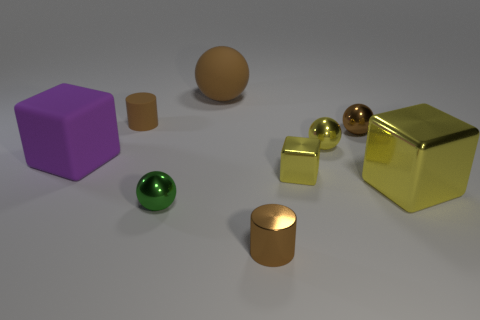Are there more brown matte balls than blue shiny balls?
Provide a succinct answer. Yes. Do the large yellow metallic object and the big brown matte object have the same shape?
Keep it short and to the point. No. There is a small cylinder that is in front of the big cube that is left of the tiny brown shiny ball; what is it made of?
Your answer should be compact. Metal. There is a tiny sphere that is the same color as the big rubber sphere; what is its material?
Your response must be concise. Metal. Do the purple rubber thing and the green metal thing have the same size?
Offer a terse response. No. There is a small thing that is in front of the tiny green shiny sphere; is there a matte cylinder in front of it?
Make the answer very short. No. The shiny sphere that is the same color as the big metal block is what size?
Provide a succinct answer. Small. What is the shape of the brown metal object that is on the left side of the tiny brown metallic sphere?
Give a very brief answer. Cylinder. What number of small metallic spheres are right of the rubber cylinder that is left of the tiny yellow object in front of the big purple matte object?
Offer a terse response. 3. There is a yellow metallic sphere; is its size the same as the brown cylinder in front of the small green sphere?
Your answer should be very brief. Yes. 